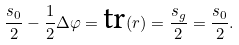<formula> <loc_0><loc_0><loc_500><loc_500>\frac { s _ { 0 } } { 2 } - \frac { 1 } { 2 } \Delta \varphi = \text {tr} ( r ) = \frac { s _ { g } } { 2 } = \frac { s _ { 0 } } { 2 } .</formula> 